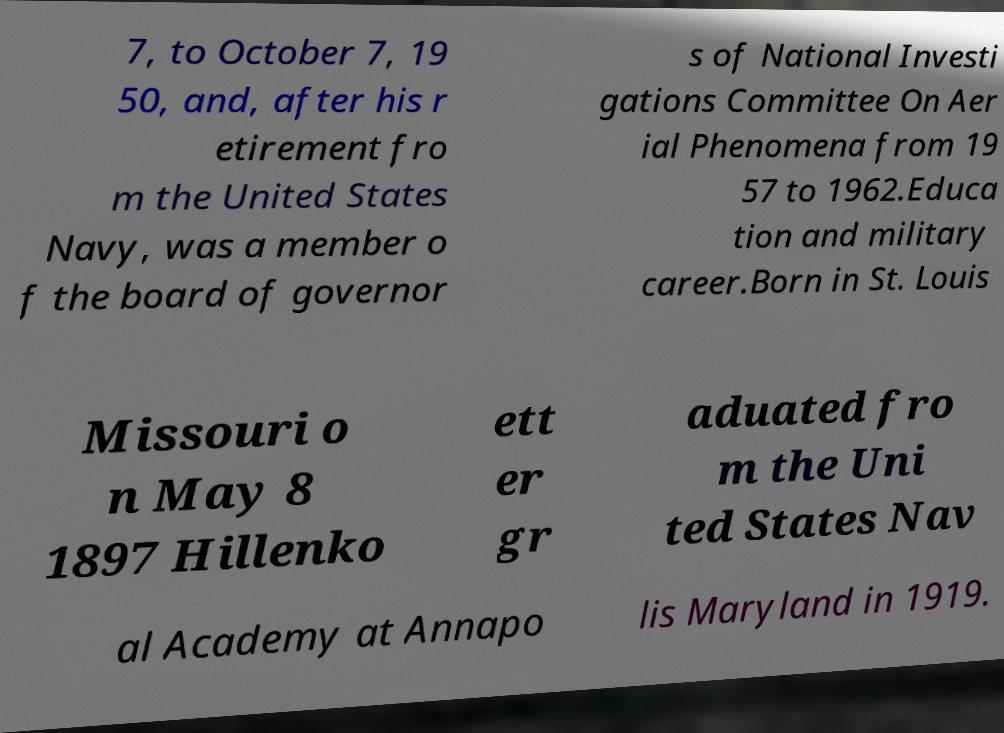What messages or text are displayed in this image? I need them in a readable, typed format. 7, to October 7, 19 50, and, after his r etirement fro m the United States Navy, was a member o f the board of governor s of National Investi gations Committee On Aer ial Phenomena from 19 57 to 1962.Educa tion and military career.Born in St. Louis Missouri o n May 8 1897 Hillenko ett er gr aduated fro m the Uni ted States Nav al Academy at Annapo lis Maryland in 1919. 